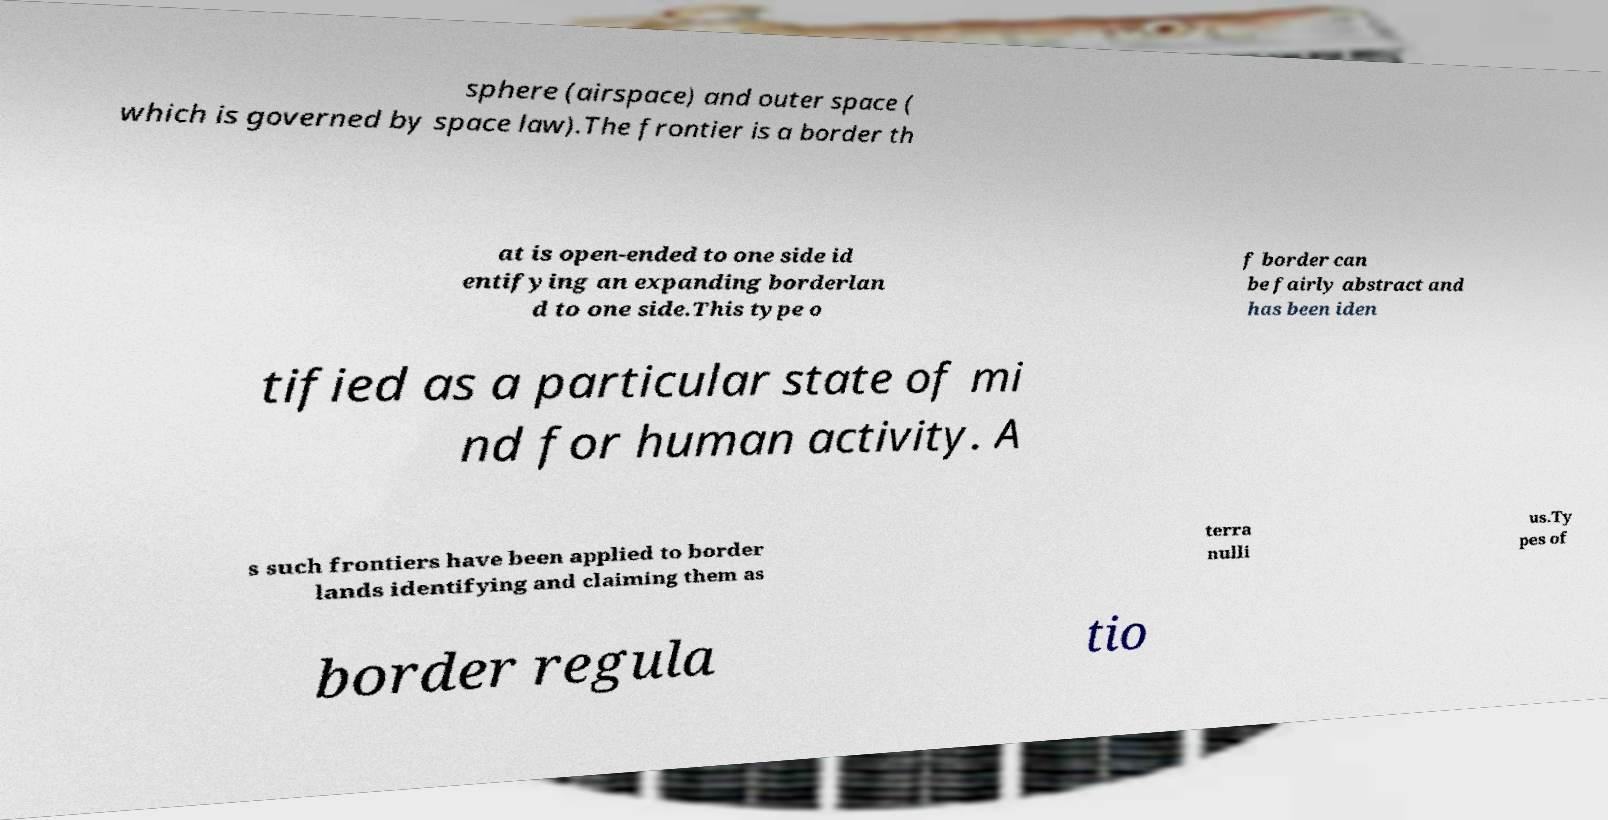Could you extract and type out the text from this image? sphere (airspace) and outer space ( which is governed by space law).The frontier is a border th at is open-ended to one side id entifying an expanding borderlan d to one side.This type o f border can be fairly abstract and has been iden tified as a particular state of mi nd for human activity. A s such frontiers have been applied to border lands identifying and claiming them as terra nulli us.Ty pes of border regula tio 